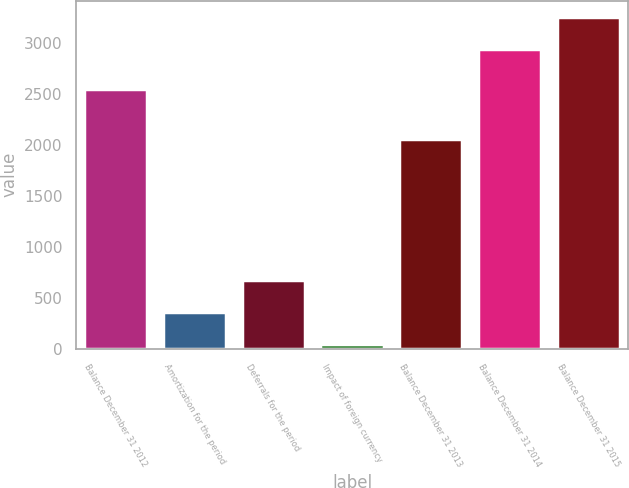<chart> <loc_0><loc_0><loc_500><loc_500><bar_chart><fcel>Balance December 31 2012<fcel>Amortization for the period<fcel>Deferrals for the period<fcel>Impact of foreign currency<fcel>Balance December 31 2013<fcel>Balance December 31 2014<fcel>Balance December 31 2015<nl><fcel>2548<fcel>363.2<fcel>675.4<fcel>51<fcel>2065<fcel>2946<fcel>3258.2<nl></chart> 